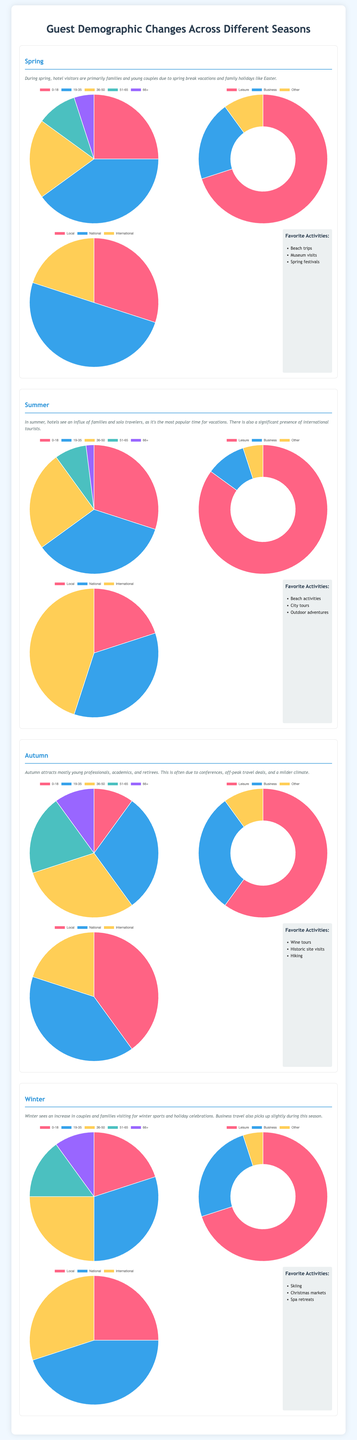What is the primary visitor demographic in spring? In spring, hotel visitors are primarily families and young couples.
Answer: Families and young couples What percentage of visitors in summer are here for leisure? In summer, 85% of visitors come for leisure.
Answer: 85% What is the most common age group in autumn? The most common age group in autumn is 19-35 years old, which comprises 30% of the visitors.
Answer: 19-35 Which season has the highest percentage of international visitors? Summer has the highest percentage of international visitors, at 45%.
Answer: Summer What is one of the favorite activities for visitors in winter? One of the favorite activities for winter visitors is skiing.
Answer: Skiing How many age groups are represented in the spring demographic chart? The spring demographic chart represents five age groups: 0-18, 19-35, 36-50, 51-65, and 66+.
Answer: Five age groups What activity is popular among autumn visitors? Wine tours are popular among autumn visitors.
Answer: Wine tours What is the purpose of visit breakdown for winter visitors? The purpose of visit breakdown for winter is 70% leisure, 25% business, and 5% other.
Answer: 70% leisure, 25% business, 5% other What geographical distribution percentage corresponds to local visitors in spring? Local visitors in spring make up 30% of the total.
Answer: 30% 